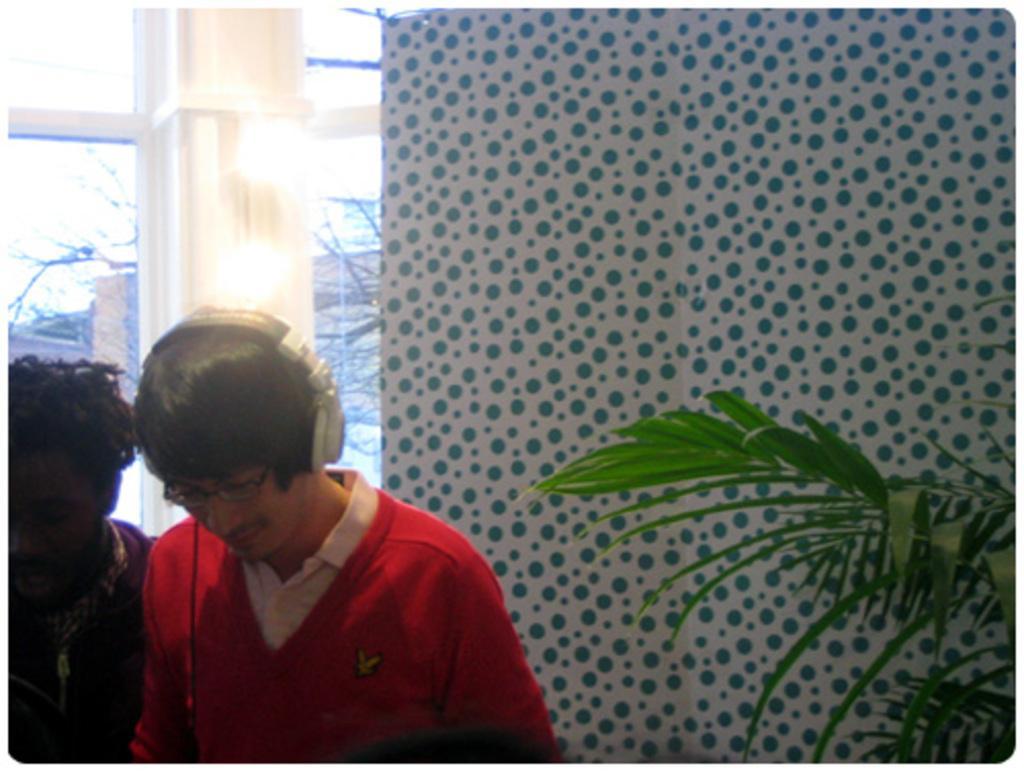Describe this image in one or two sentences. In this image on the left side there are two persons and in the background there is a wall, glass window, pillar and plant. 